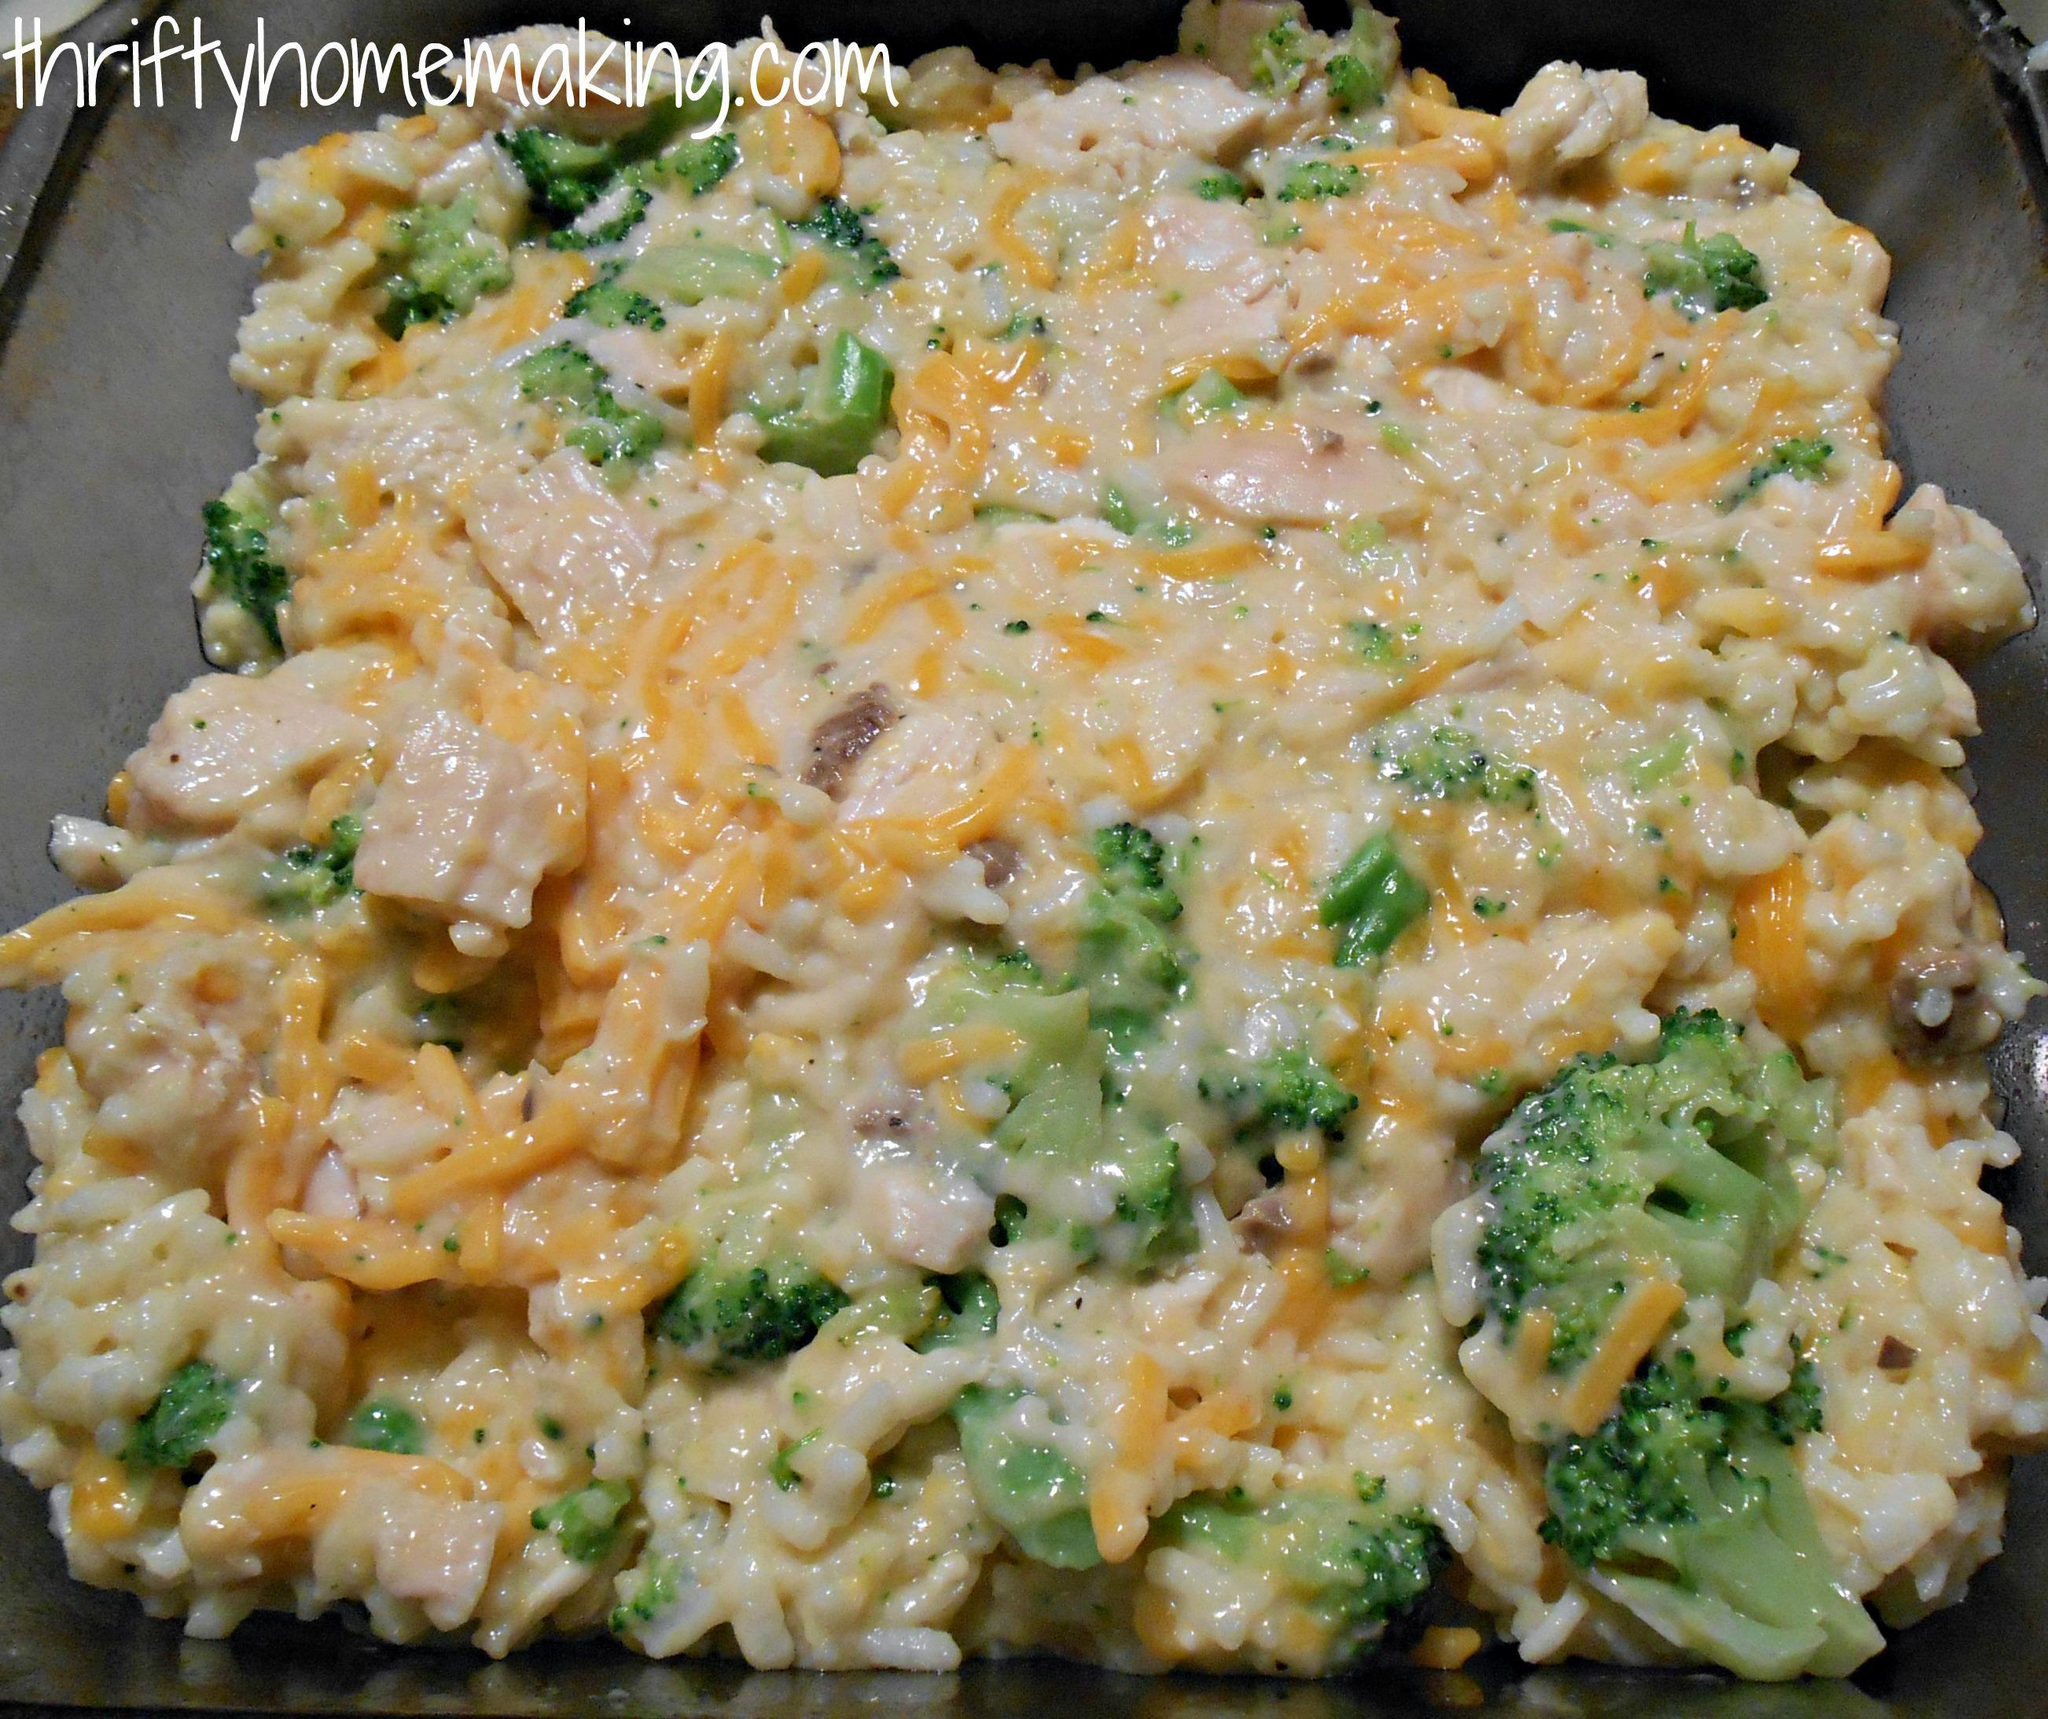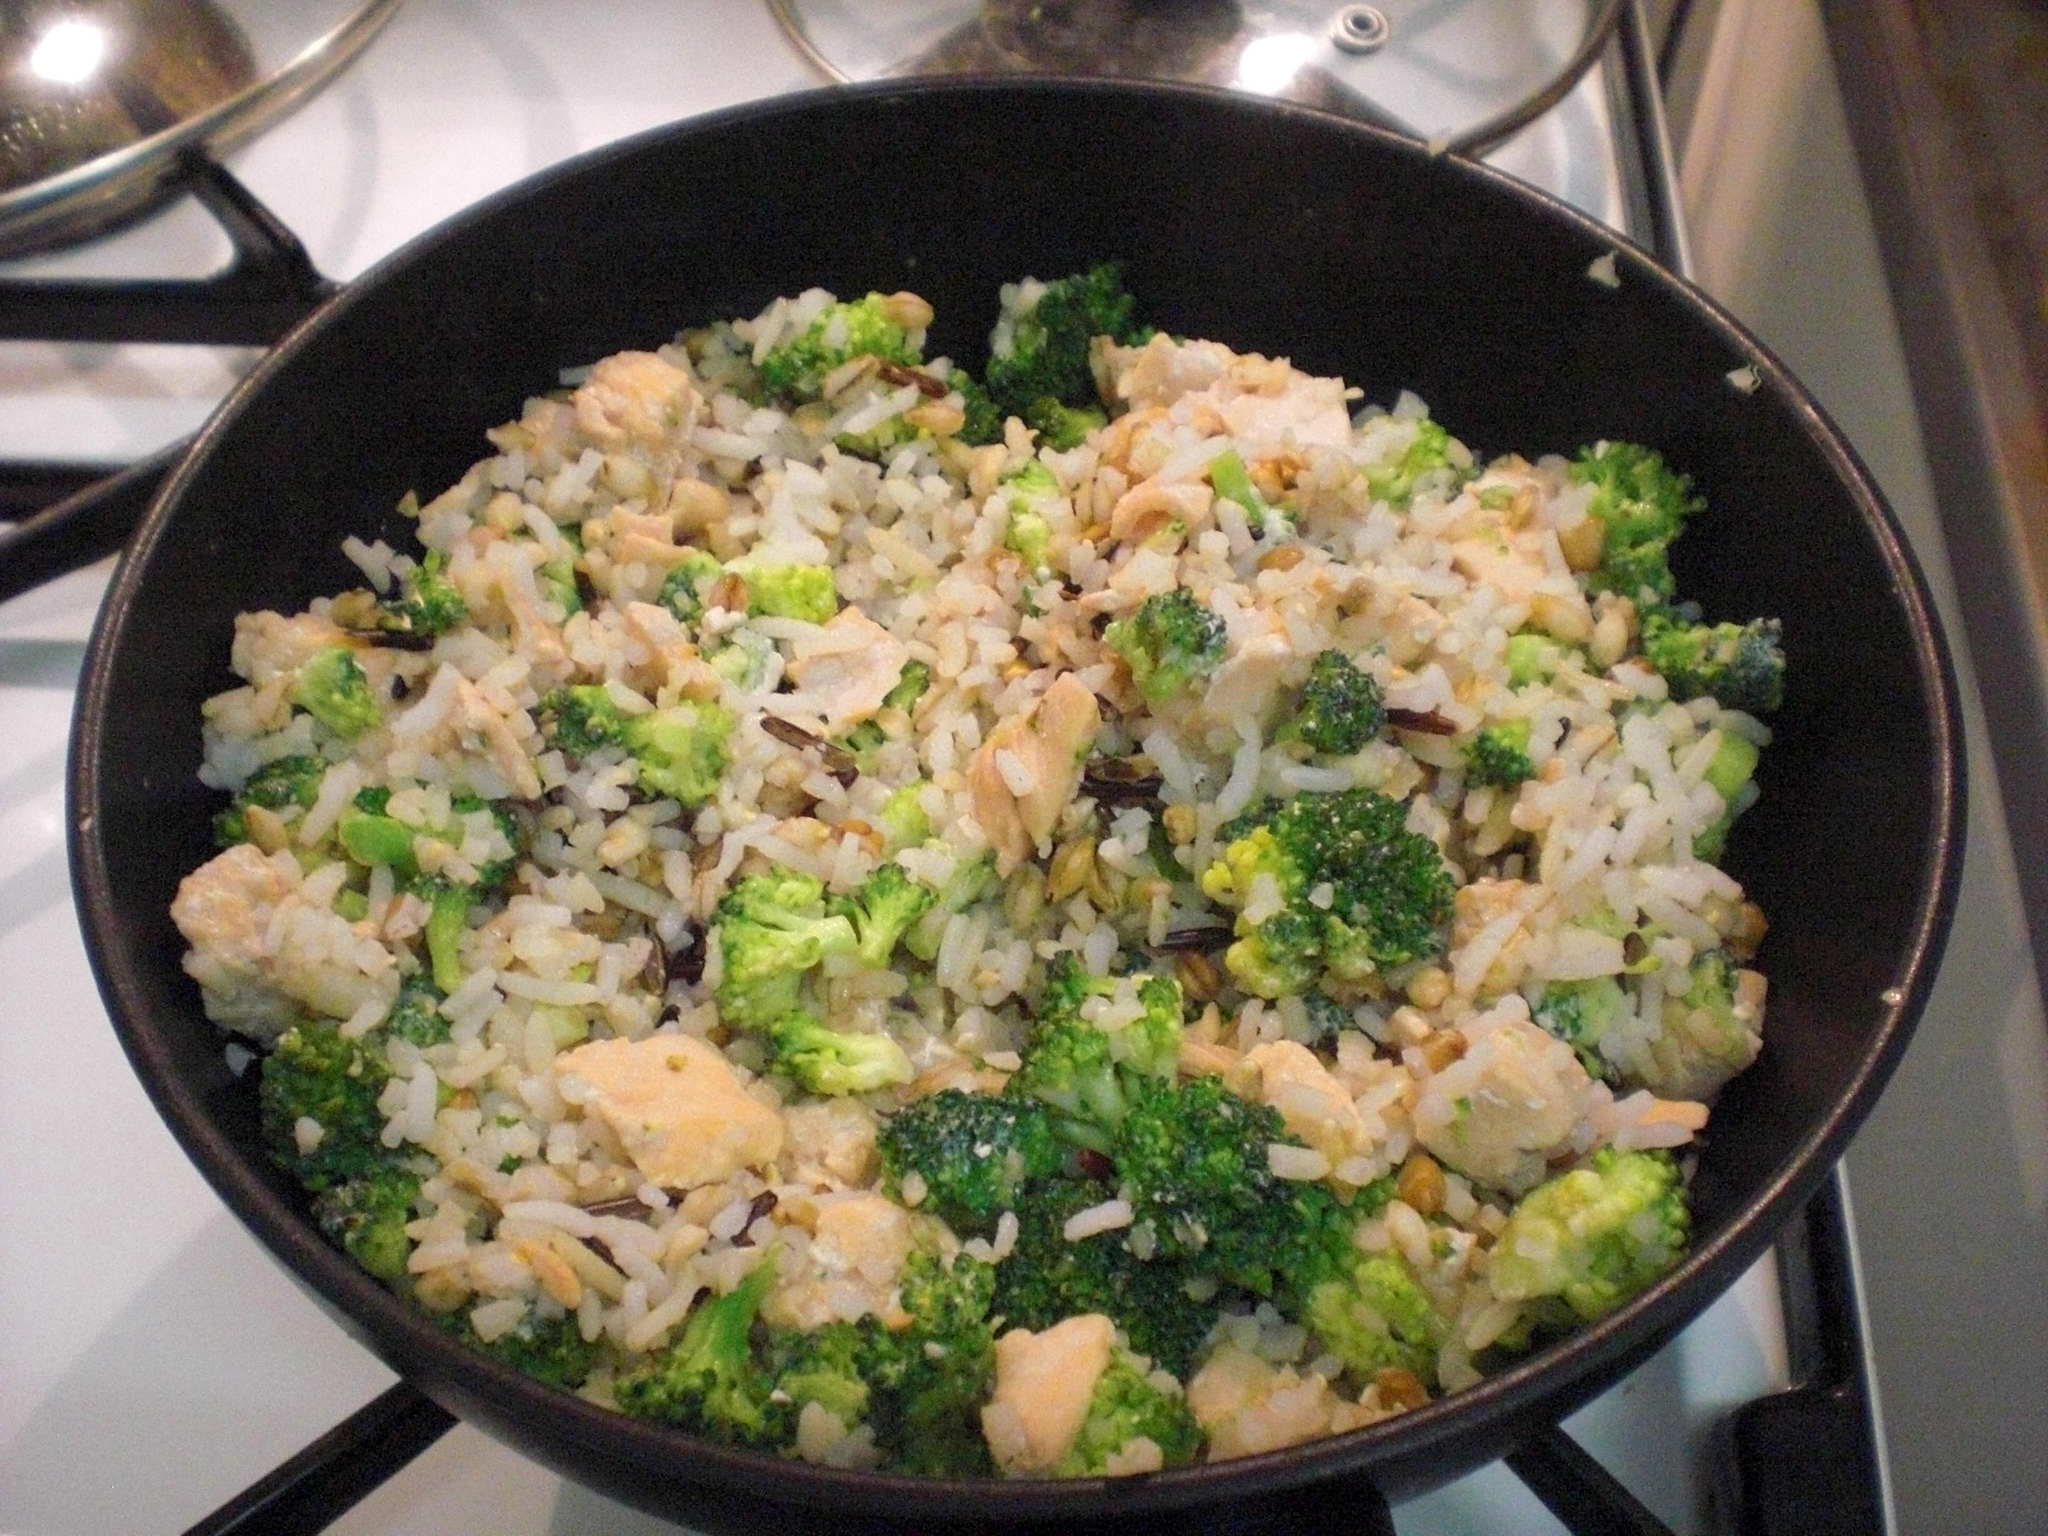The first image is the image on the left, the second image is the image on the right. Assess this claim about the two images: "the rice on the left image is on a white plate". Correct or not? Answer yes or no. No. 